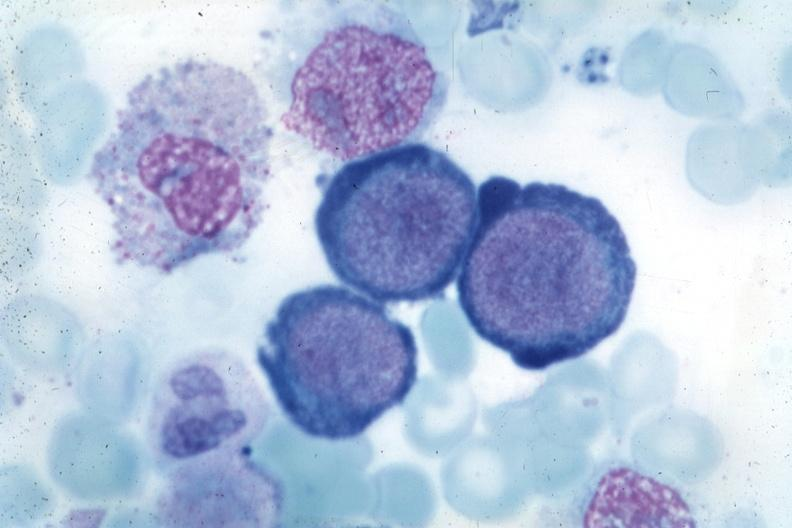what is present?
Answer the question using a single word or phrase. Hematologic 